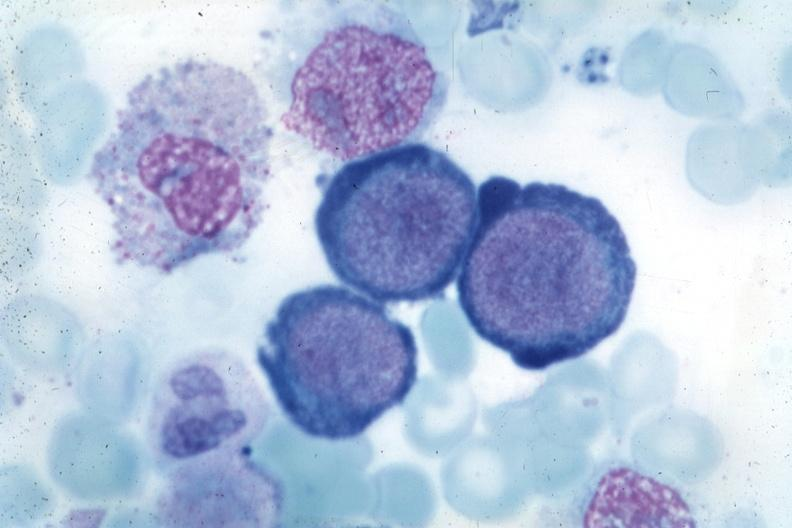what is present?
Answer the question using a single word or phrase. Hematologic 